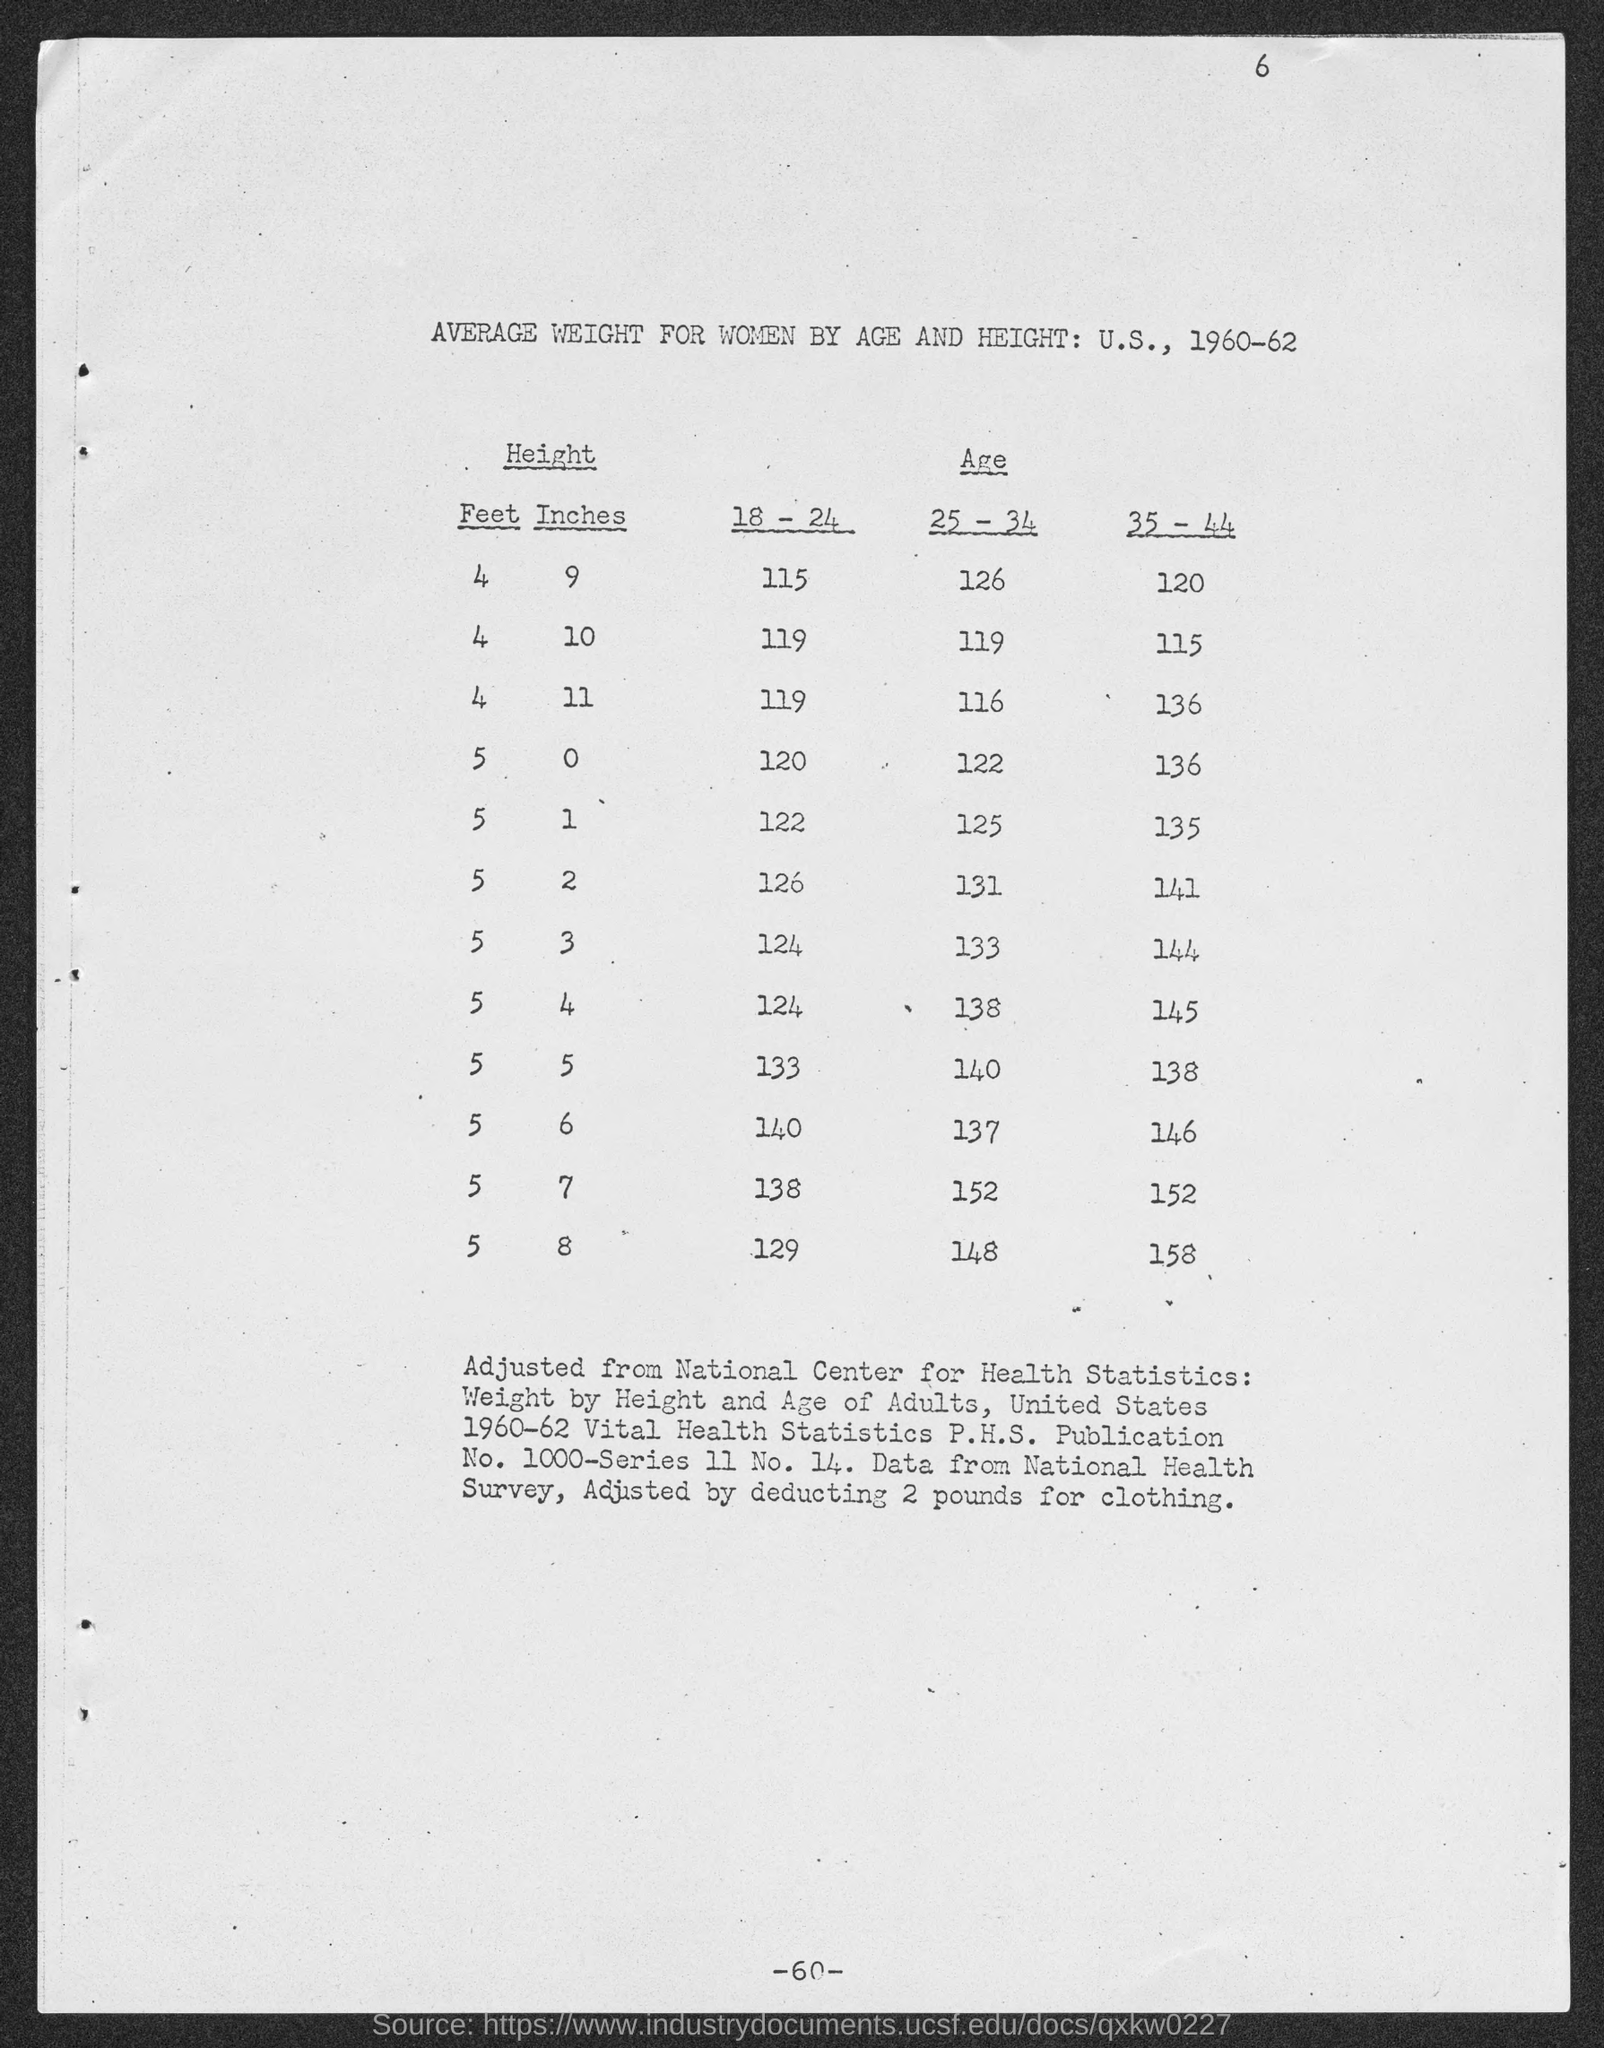What is the table title?
Your answer should be compact. AVERAGE WEIGHT FOR WOMEN BY AGE AND HEIGHT: U.S., 1960-62. What is the average weight of people in age group 18-24 and height 4 feet 9 inches?
Provide a short and direct response. 115. How much has been deducted for clothing?
Give a very brief answer. 2 pounds. 